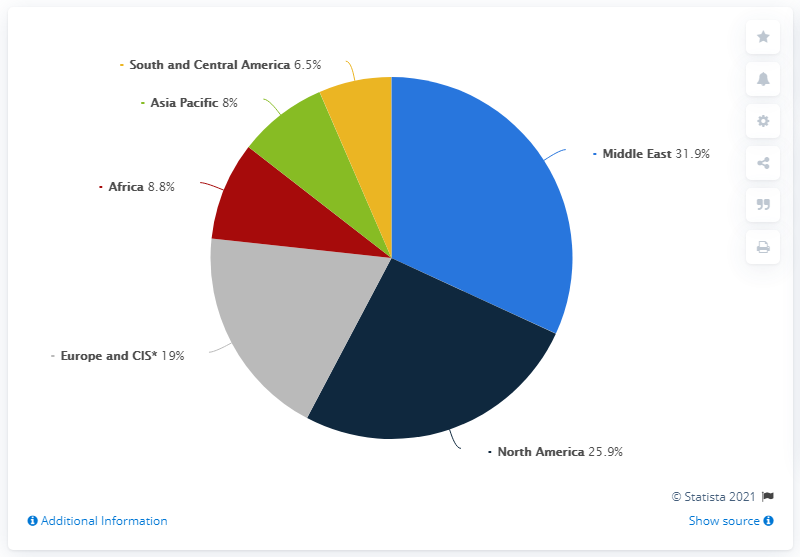Specify some key components in this picture. In 2019, the Middle East accounted for approximately 31.9% of the total oil produced globally. There are three colored segments that are less than 10. The average global oil production, when compared to the smallest production among all countries, results in a value of 10.17. 